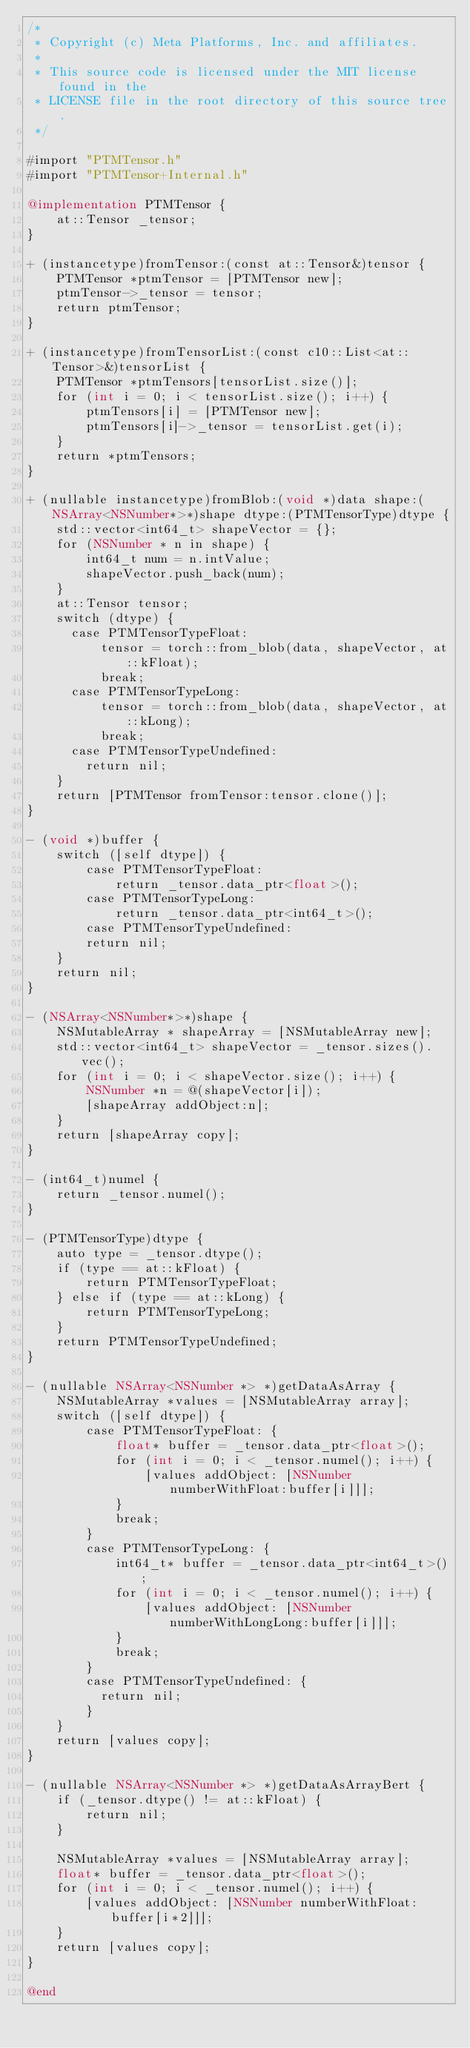Convert code to text. <code><loc_0><loc_0><loc_500><loc_500><_ObjectiveC_>/*
 * Copyright (c) Meta Platforms, Inc. and affiliates.
 *
 * This source code is licensed under the MIT license found in the
 * LICENSE file in the root directory of this source tree.
 */

#import "PTMTensor.h"
#import "PTMTensor+Internal.h"

@implementation PTMTensor {
    at::Tensor _tensor;
}

+ (instancetype)fromTensor:(const at::Tensor&)tensor {
    PTMTensor *ptmTensor = [PTMTensor new];
    ptmTensor->_tensor = tensor;
    return ptmTensor;
}

+ (instancetype)fromTensorList:(const c10::List<at::Tensor>&)tensorList {
    PTMTensor *ptmTensors[tensorList.size()];
    for (int i = 0; i < tensorList.size(); i++) {
        ptmTensors[i] = [PTMTensor new];
        ptmTensors[i]->_tensor = tensorList.get(i);
    }
    return *ptmTensors;
}

+ (nullable instancetype)fromBlob:(void *)data shape:(NSArray<NSNumber*>*)shape dtype:(PTMTensorType)dtype {
    std::vector<int64_t> shapeVector = {};
    for (NSNumber * n in shape) {
        int64_t num = n.intValue;
        shapeVector.push_back(num);
    }
    at::Tensor tensor;
    switch (dtype) {
      case PTMTensorTypeFloat:
          tensor = torch::from_blob(data, shapeVector, at::kFloat);
          break;
      case PTMTensorTypeLong:
          tensor = torch::from_blob(data, shapeVector, at::kLong);
          break;
      case PTMTensorTypeUndefined:
        return nil;
    }
    return [PTMTensor fromTensor:tensor.clone()];
}

- (void *)buffer {
    switch ([self dtype]) {
        case PTMTensorTypeFloat:
            return _tensor.data_ptr<float>();
        case PTMTensorTypeLong:
            return _tensor.data_ptr<int64_t>();
        case PTMTensorTypeUndefined:
        return nil;
    }
    return nil;
}

- (NSArray<NSNumber*>*)shape {
    NSMutableArray * shapeArray = [NSMutableArray new];
    std::vector<int64_t> shapeVector = _tensor.sizes().vec();
    for (int i = 0; i < shapeVector.size(); i++) {
        NSNumber *n = @(shapeVector[i]);
        [shapeArray addObject:n];
    }
    return [shapeArray copy];
}

- (int64_t)numel {
    return _tensor.numel();
}

- (PTMTensorType)dtype {
    auto type = _tensor.dtype();
    if (type == at::kFloat) {
        return PTMTensorTypeFloat;
    } else if (type == at::kLong) {
        return PTMTensorTypeLong;
    }
    return PTMTensorTypeUndefined;
}

- (nullable NSArray<NSNumber *> *)getDataAsArray {
    NSMutableArray *values = [NSMutableArray array];
    switch ([self dtype]) {
        case PTMTensorTypeFloat: {
            float* buffer = _tensor.data_ptr<float>();
            for (int i = 0; i < _tensor.numel(); i++) {
                [values addObject: [NSNumber numberWithFloat:buffer[i]]];
            }
            break;
        }
        case PTMTensorTypeLong: {
            int64_t* buffer = _tensor.data_ptr<int64_t>();
            for (int i = 0; i < _tensor.numel(); i++) {
                [values addObject: [NSNumber numberWithLongLong:buffer[i]]];
            }
            break;
        }
        case PTMTensorTypeUndefined: {
          return nil;
        }
    }
    return [values copy];
}

- (nullable NSArray<NSNumber *> *)getDataAsArrayBert {
    if (_tensor.dtype() != at::kFloat) {
        return nil;
    }
    
    NSMutableArray *values = [NSMutableArray array];
    float* buffer = _tensor.data_ptr<float>();
    for (int i = 0; i < _tensor.numel(); i++) {
        [values addObject: [NSNumber numberWithFloat:buffer[i*2]]];
    }
    return [values copy];
}

@end
</code> 